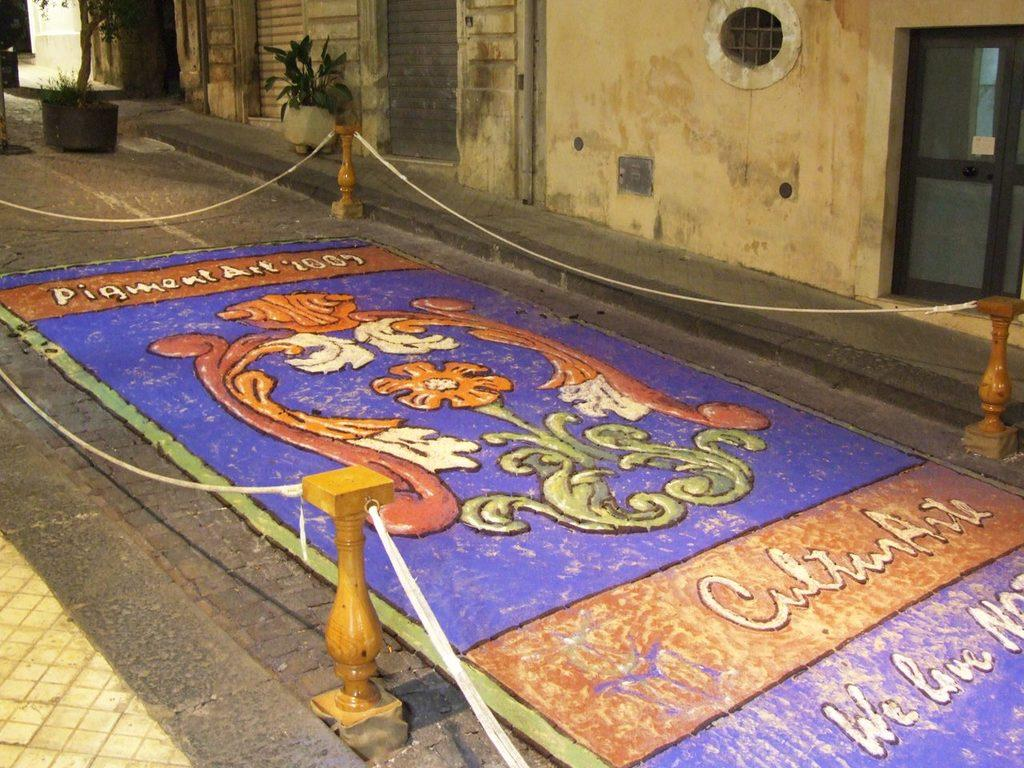What is placed on the ground in the image? There is a painting on the ground in the image. What objects can be seen in the image besides the painting? There are poles, ropes, and plants placed on the ground in the image. What can be seen in the background of the image? There is a building with a window and a door in the background of the image. What rule is being enforced by the painting in the image? There is no rule being enforced by the painting in the image; it is simply a painting placed on the ground. 